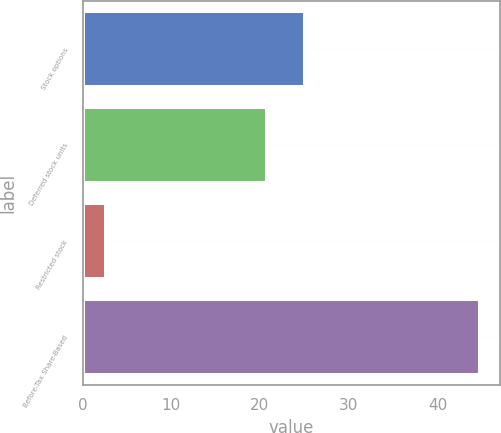<chart> <loc_0><loc_0><loc_500><loc_500><bar_chart><fcel>Stock options<fcel>Deferred stock units<fcel>Restricted stock<fcel>Before-Tax Share-Based<nl><fcel>25.02<fcel>20.8<fcel>2.6<fcel>44.8<nl></chart> 